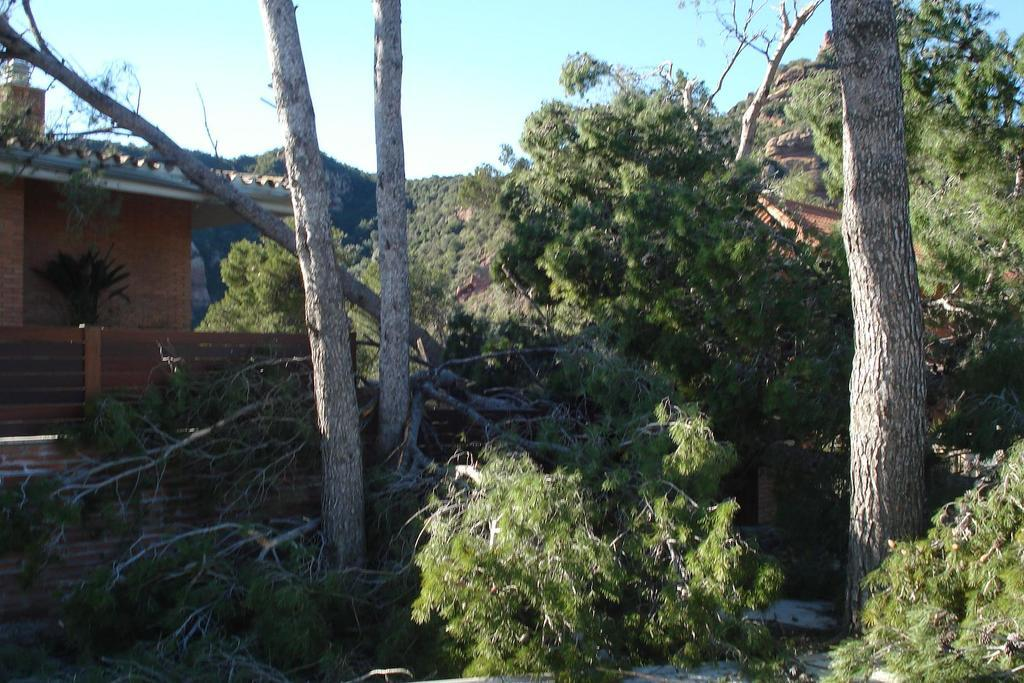What type of structures are present in the image? There are houses in the image. What other natural elements can be seen in the image? There are trees and rocks in the image. What is visible in the background of the image? The sky is visible in the background of the image. Can you hear the bell ringing in the image? There is no bell present in the image, so it cannot be heard. 